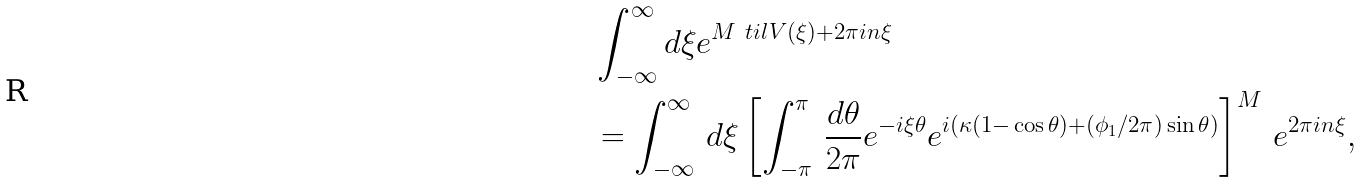Convert formula to latex. <formula><loc_0><loc_0><loc_500><loc_500>& \int _ { - \infty } ^ { \infty } d \xi e ^ { M \ t i l V ( \xi ) + 2 \pi i n \xi } \\ & = \int _ { - \infty } ^ { \infty } \, d \xi \left [ \int _ { - \pi } ^ { \pi } \, \frac { d \theta } { 2 \pi } e ^ { - i \xi \theta } e ^ { i ( \kappa ( 1 { - } \cos \theta ) + ( \phi _ { 1 } / 2 \pi ) \sin \theta ) } \right ] ^ { M } \, e ^ { 2 \pi i n \xi } ,</formula> 